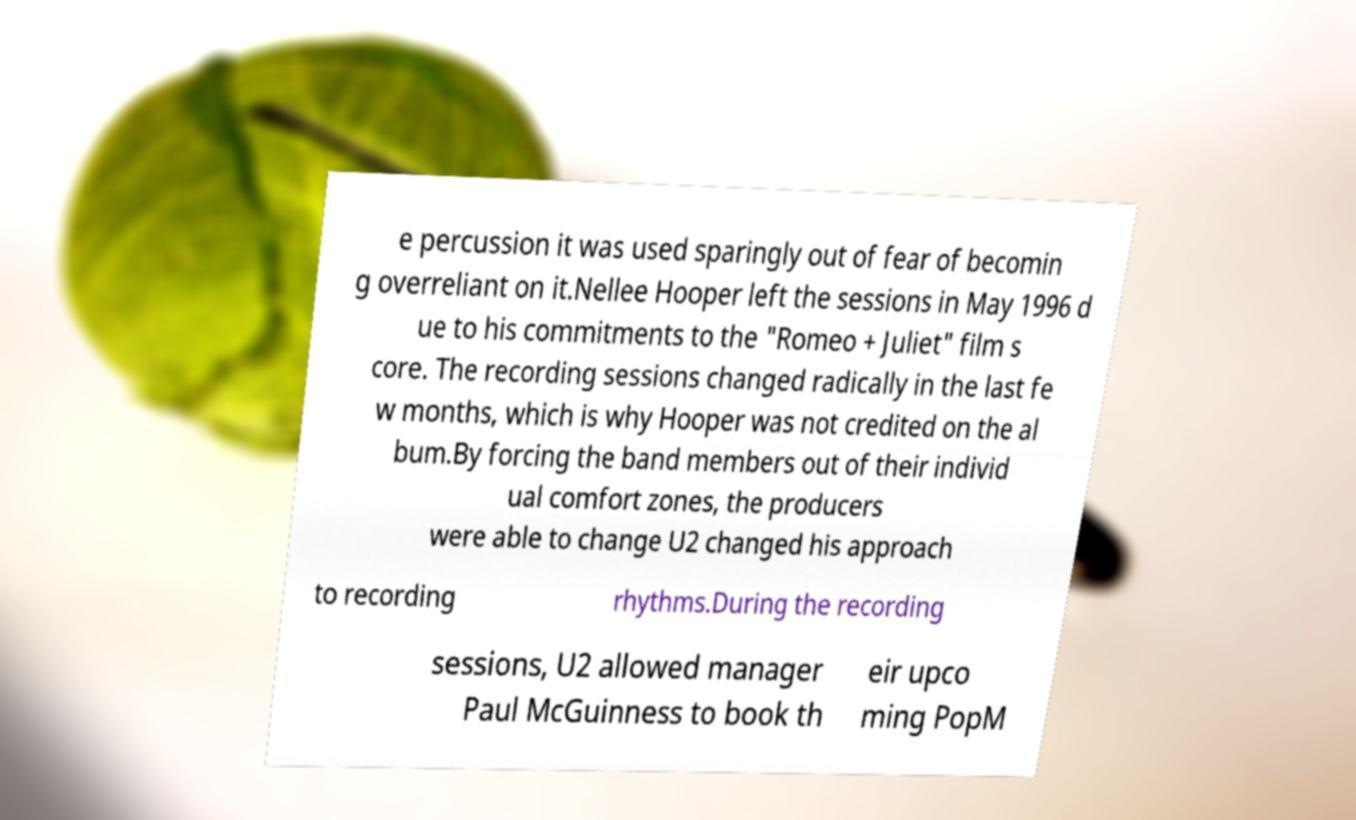Can you read and provide the text displayed in the image?This photo seems to have some interesting text. Can you extract and type it out for me? e percussion it was used sparingly out of fear of becomin g overreliant on it.Nellee Hooper left the sessions in May 1996 d ue to his commitments to the "Romeo + Juliet" film s core. The recording sessions changed radically in the last fe w months, which is why Hooper was not credited on the al bum.By forcing the band members out of their individ ual comfort zones, the producers were able to change U2 changed his approach to recording rhythms.During the recording sessions, U2 allowed manager Paul McGuinness to book th eir upco ming PopM 